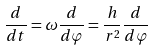Convert formula to latex. <formula><loc_0><loc_0><loc_500><loc_500>\frac { d } { d t } = \omega \frac { d } { d \varphi } = \frac { h } { r ^ { 2 } } \frac { d } { d \varphi }</formula> 